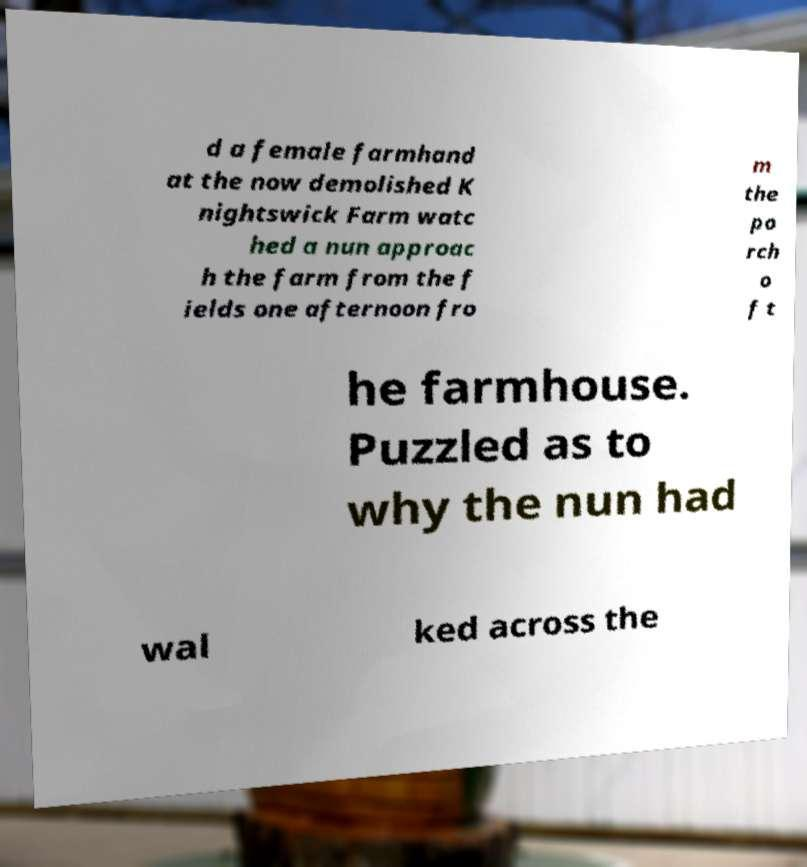For documentation purposes, I need the text within this image transcribed. Could you provide that? d a female farmhand at the now demolished K nightswick Farm watc hed a nun approac h the farm from the f ields one afternoon fro m the po rch o f t he farmhouse. Puzzled as to why the nun had wal ked across the 